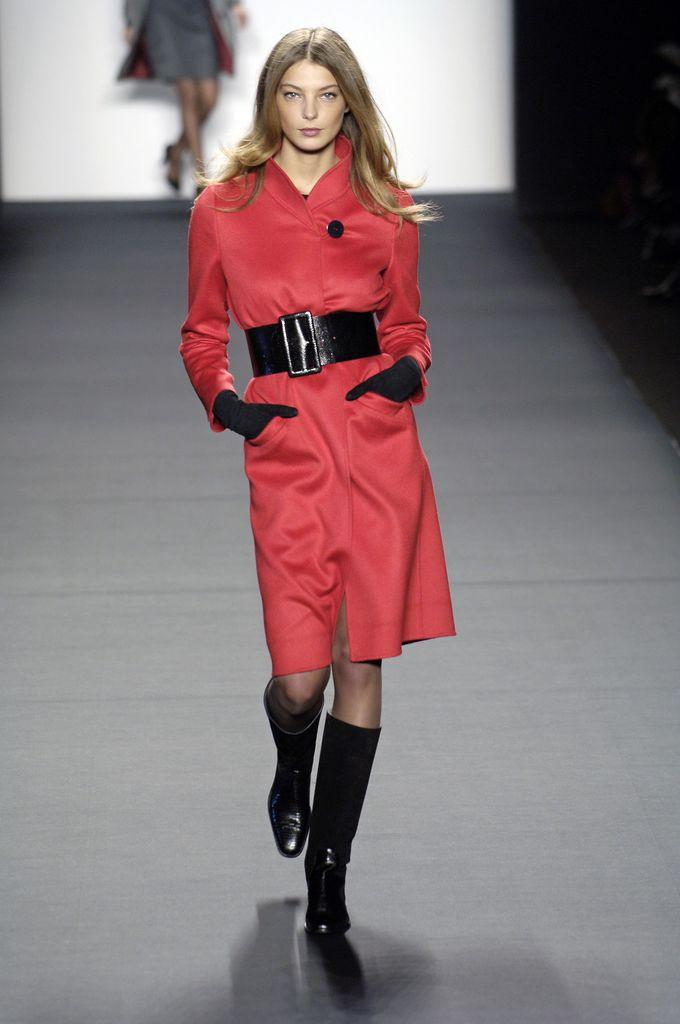Who is the main subject in the image? There is a woman in the image. What is the woman doing in the image? The woman is walking on a ramp. Where is the ramp located in the image? The ramp is in the foreground of the image. What type of scent can be smelled coming from the ramp in the image? There is no indication of a scent in the image, so it cannot be smelled. 